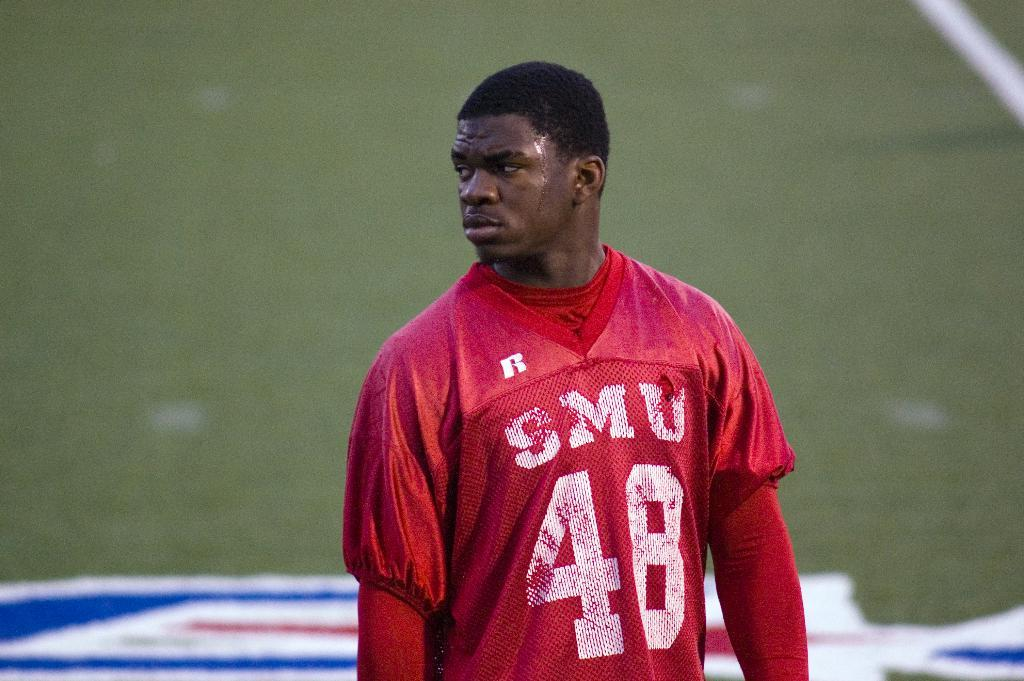<image>
Share a concise interpretation of the image provided. a man wearing a red jersey that says 'smu 48' on it 